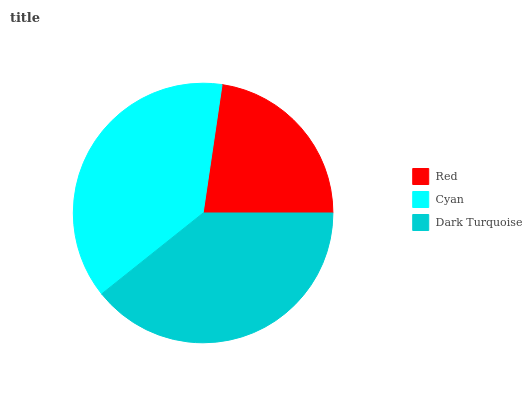Is Red the minimum?
Answer yes or no. Yes. Is Dark Turquoise the maximum?
Answer yes or no. Yes. Is Cyan the minimum?
Answer yes or no. No. Is Cyan the maximum?
Answer yes or no. No. Is Cyan greater than Red?
Answer yes or no. Yes. Is Red less than Cyan?
Answer yes or no. Yes. Is Red greater than Cyan?
Answer yes or no. No. Is Cyan less than Red?
Answer yes or no. No. Is Cyan the high median?
Answer yes or no. Yes. Is Cyan the low median?
Answer yes or no. Yes. Is Dark Turquoise the high median?
Answer yes or no. No. Is Dark Turquoise the low median?
Answer yes or no. No. 